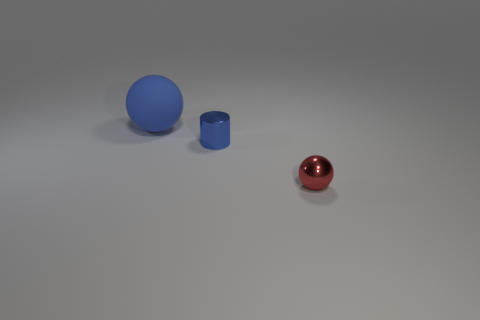Add 1 tiny red metal blocks. How many objects exist? 4 Subtract all red spheres. How many spheres are left? 1 Subtract 1 balls. How many balls are left? 1 Subtract all metal things. Subtract all big yellow matte things. How many objects are left? 1 Add 3 small blue objects. How many small blue objects are left? 4 Add 1 balls. How many balls exist? 3 Subtract 0 purple blocks. How many objects are left? 3 Subtract all cylinders. How many objects are left? 2 Subtract all yellow balls. Subtract all green cylinders. How many balls are left? 2 Subtract all brown blocks. How many blue spheres are left? 1 